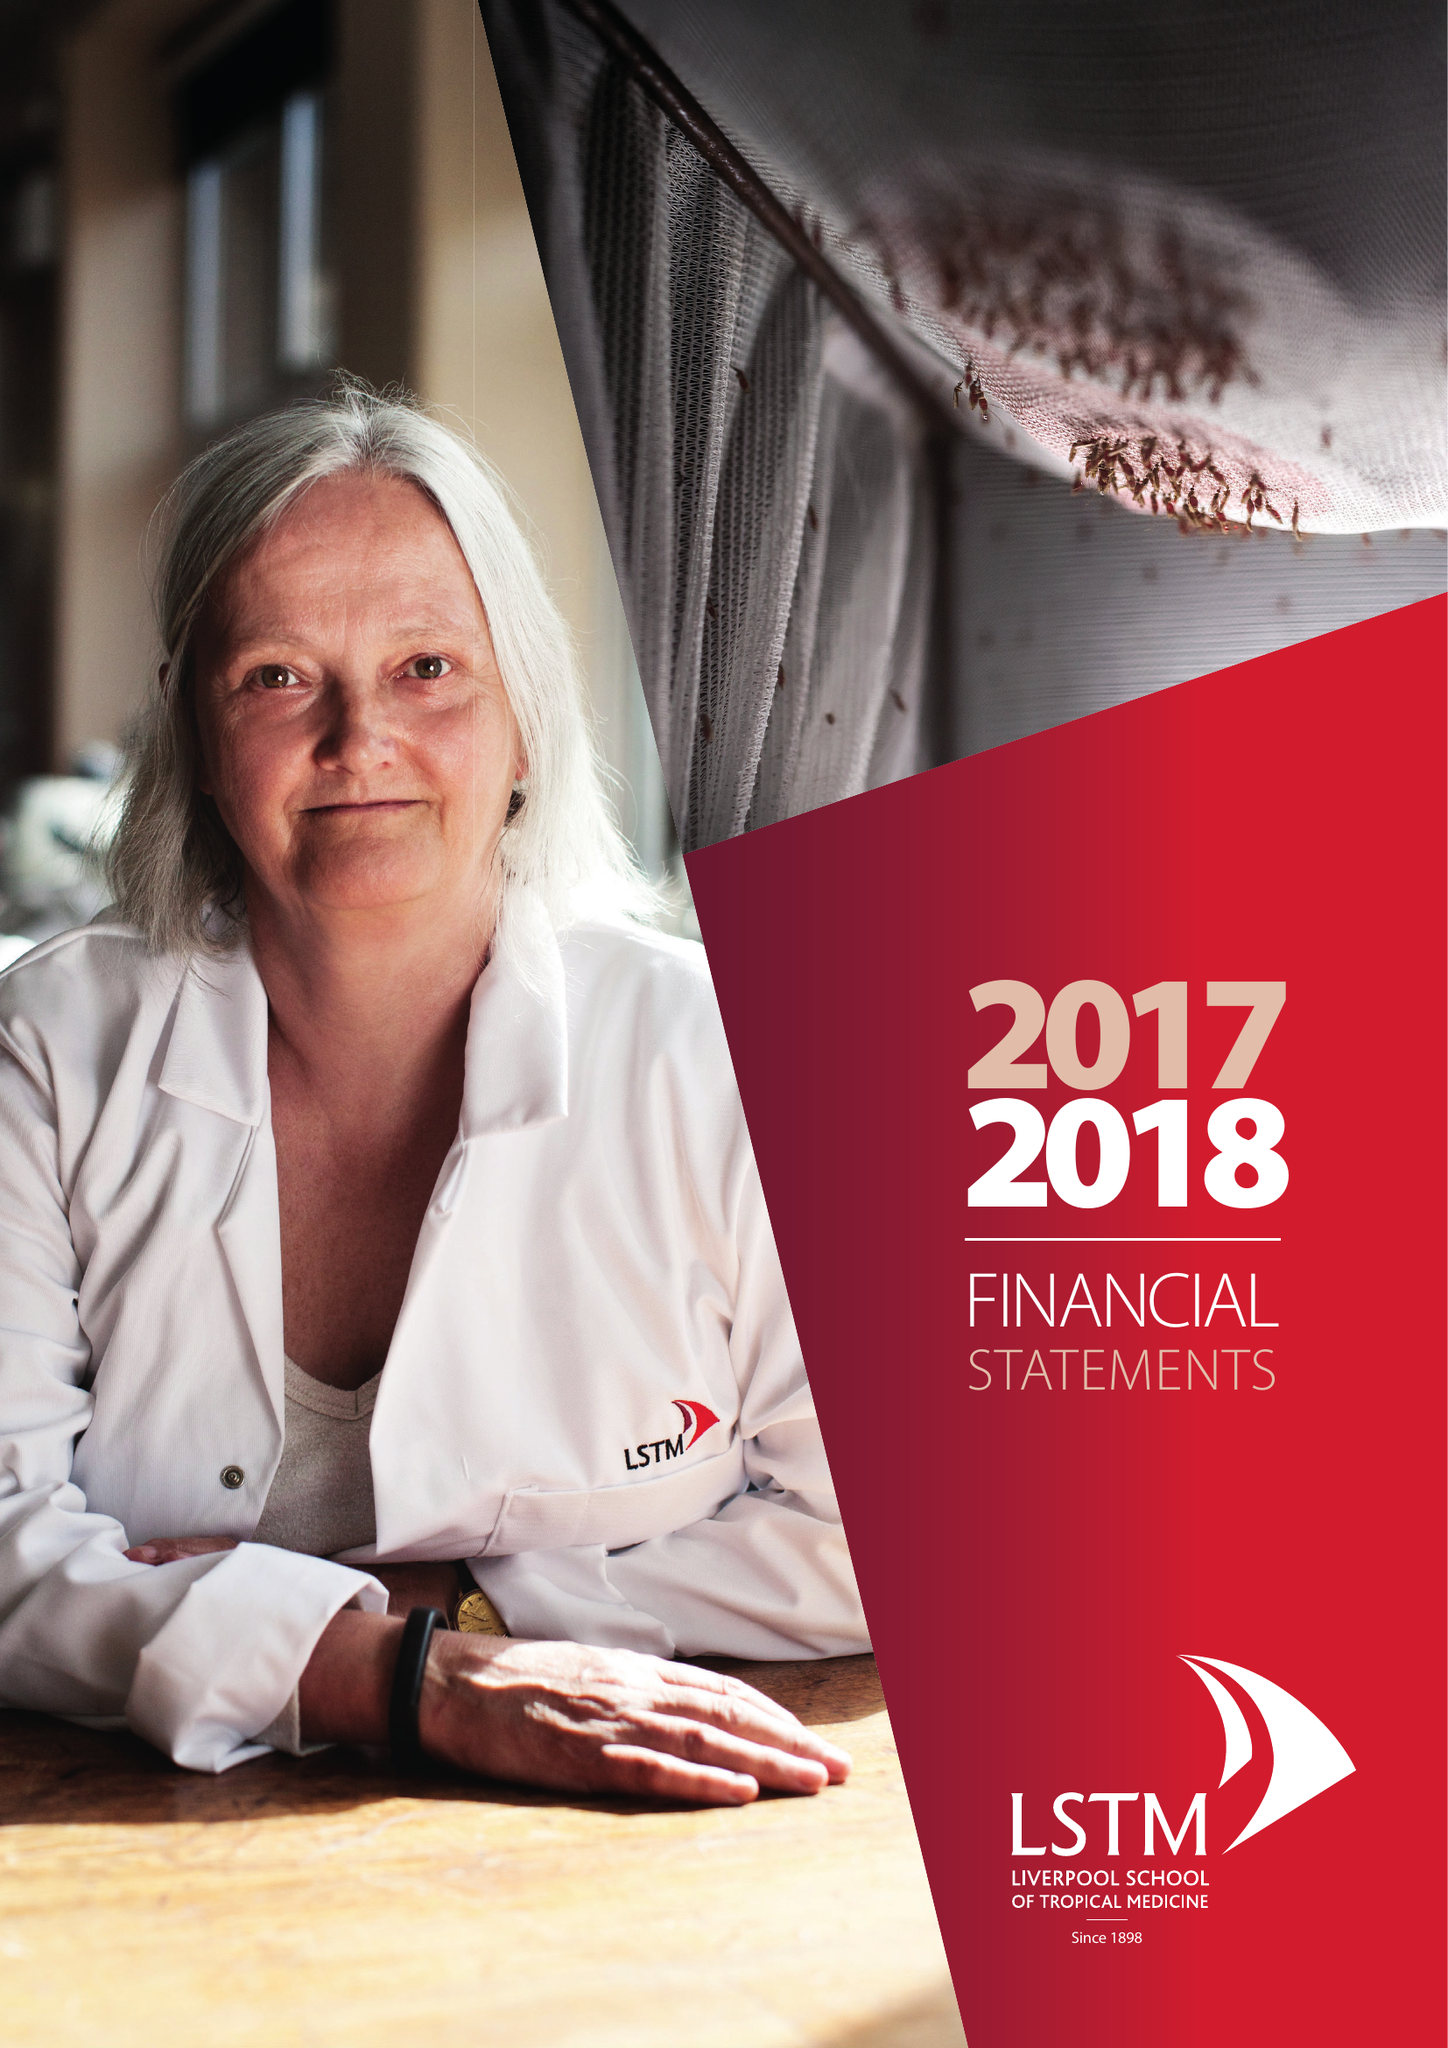What is the value for the address__postcode?
Answer the question using a single word or phrase. L3 5QA 